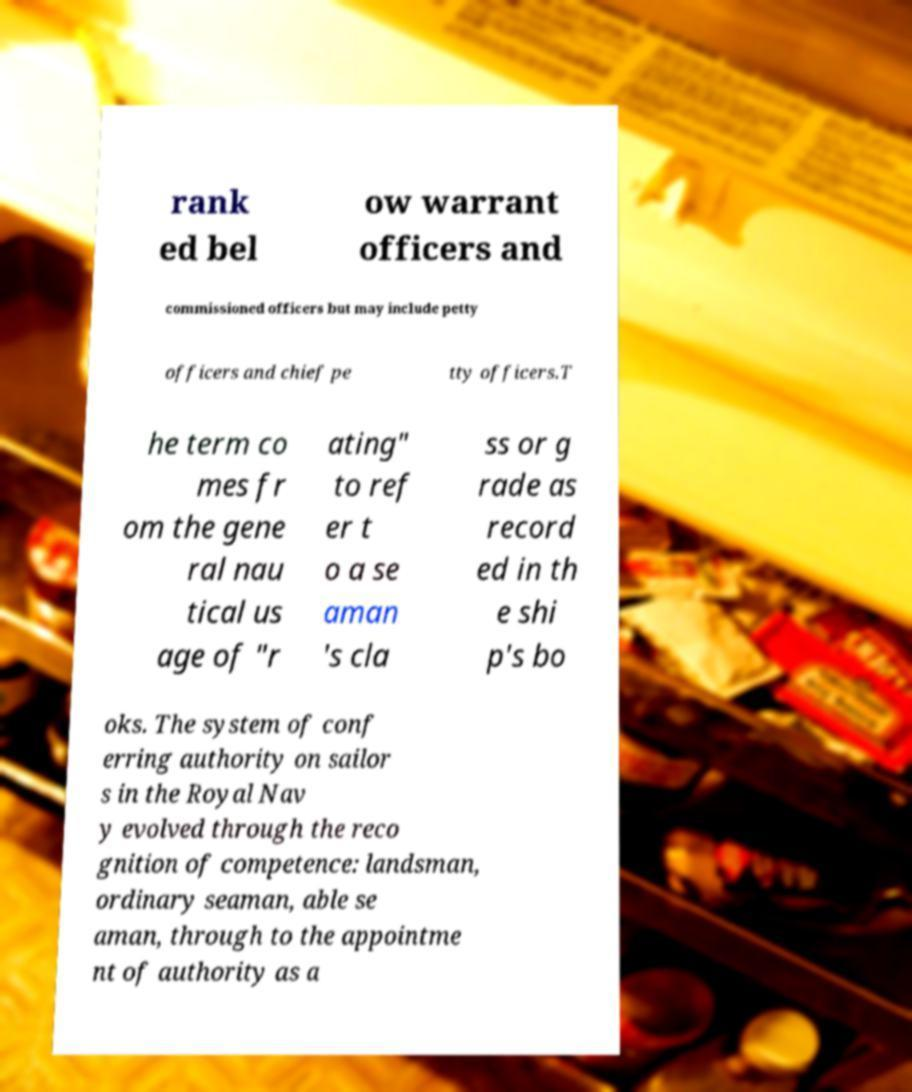Please identify and transcribe the text found in this image. rank ed bel ow warrant officers and commissioned officers but may include petty officers and chief pe tty officers.T he term co mes fr om the gene ral nau tical us age of "r ating" to ref er t o a se aman 's cla ss or g rade as record ed in th e shi p's bo oks. The system of conf erring authority on sailor s in the Royal Nav y evolved through the reco gnition of competence: landsman, ordinary seaman, able se aman, through to the appointme nt of authority as a 